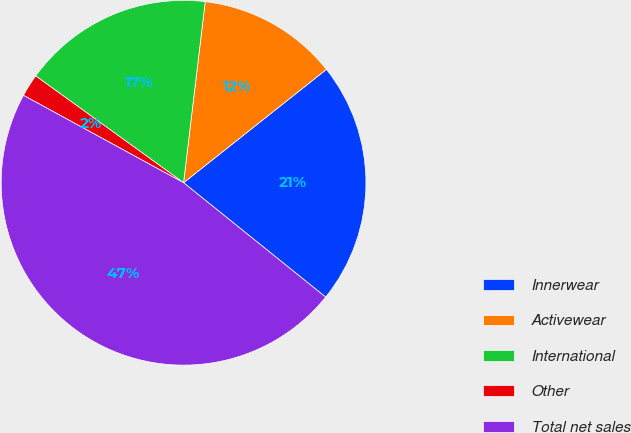Convert chart to OTSL. <chart><loc_0><loc_0><loc_500><loc_500><pie_chart><fcel>Innerwear<fcel>Activewear<fcel>International<fcel>Other<fcel>Total net sales<nl><fcel>21.46%<fcel>12.43%<fcel>16.94%<fcel>2.0%<fcel>47.17%<nl></chart> 